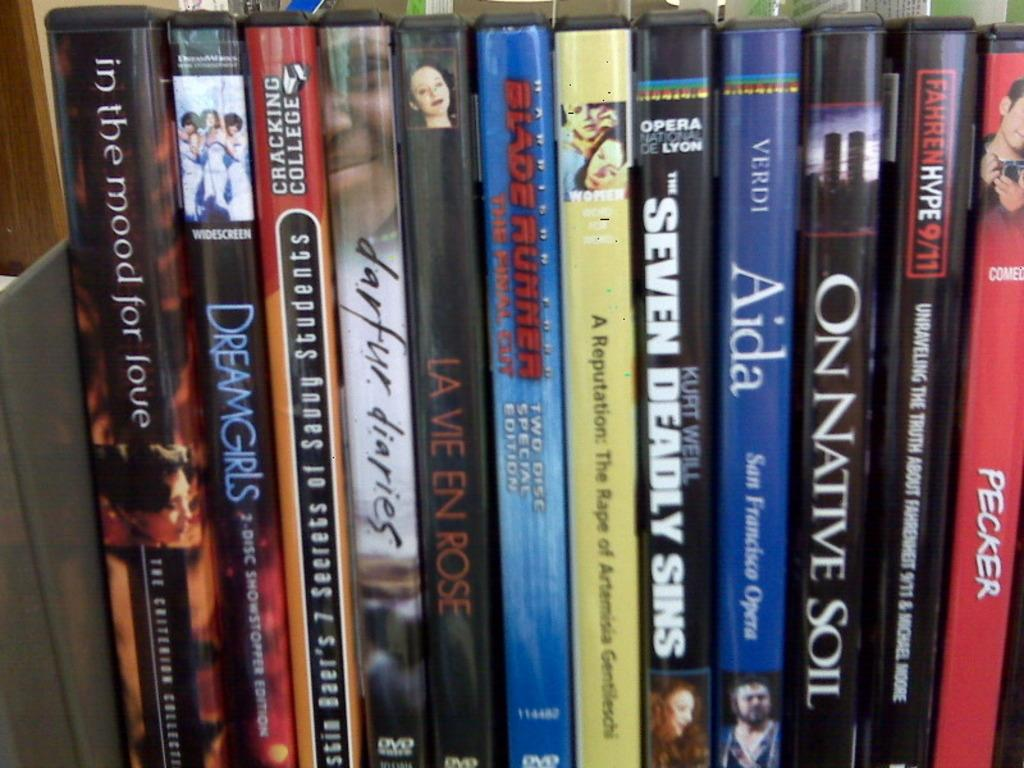Provide a one-sentence caption for the provided image. A close up view of movies with the names of "Aida" and "One Native Soil". 